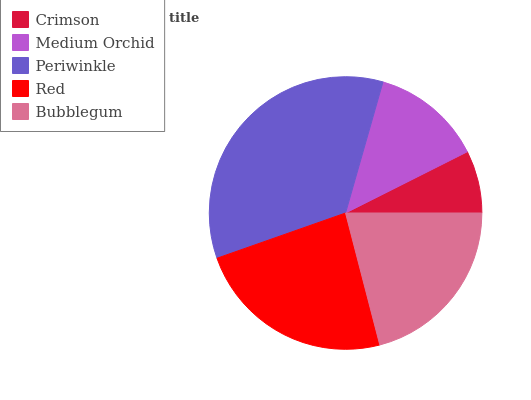Is Crimson the minimum?
Answer yes or no. Yes. Is Periwinkle the maximum?
Answer yes or no. Yes. Is Medium Orchid the minimum?
Answer yes or no. No. Is Medium Orchid the maximum?
Answer yes or no. No. Is Medium Orchid greater than Crimson?
Answer yes or no. Yes. Is Crimson less than Medium Orchid?
Answer yes or no. Yes. Is Crimson greater than Medium Orchid?
Answer yes or no. No. Is Medium Orchid less than Crimson?
Answer yes or no. No. Is Bubblegum the high median?
Answer yes or no. Yes. Is Bubblegum the low median?
Answer yes or no. Yes. Is Medium Orchid the high median?
Answer yes or no. No. Is Medium Orchid the low median?
Answer yes or no. No. 